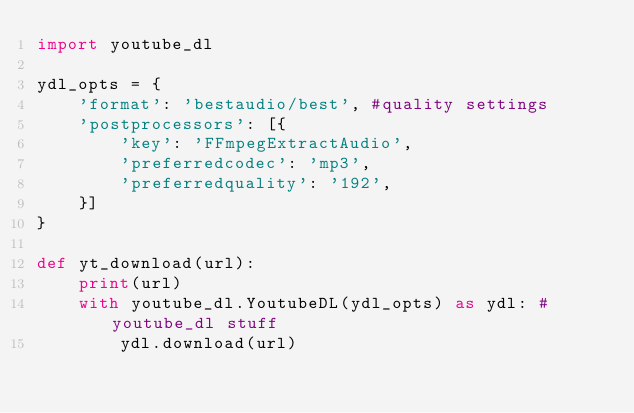Convert code to text. <code><loc_0><loc_0><loc_500><loc_500><_Python_>import youtube_dl

ydl_opts = {
    'format': 'bestaudio/best', #quality settings
    'postprocessors': [{
        'key': 'FFmpegExtractAudio',
        'preferredcodec': 'mp3',
        'preferredquality': '192',
    }]
}

def yt_download(url):
    print(url)
    with youtube_dl.YoutubeDL(ydl_opts) as ydl: #youtube_dl stuff
        ydl.download(url) </code> 